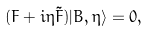Convert formula to latex. <formula><loc_0><loc_0><loc_500><loc_500>( F + i \eta \tilde { F } ) | B , \eta \rangle = 0 ,</formula> 